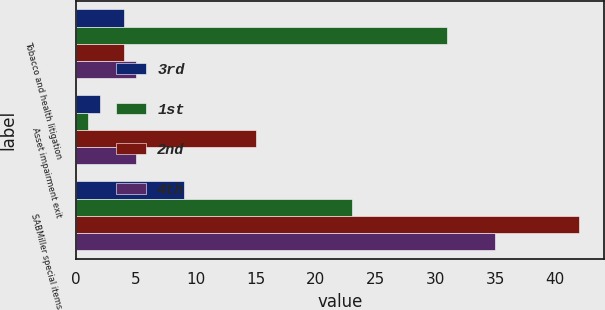Convert chart. <chart><loc_0><loc_0><loc_500><loc_500><stacked_bar_chart><ecel><fcel>Tobacco and health litigation<fcel>Asset impairment exit<fcel>SABMiller special items<nl><fcel>3rd<fcel>4<fcel>2<fcel>9<nl><fcel>1st<fcel>31<fcel>1<fcel>23<nl><fcel>2nd<fcel>4<fcel>15<fcel>42<nl><fcel>4th<fcel>5<fcel>5<fcel>35<nl></chart> 